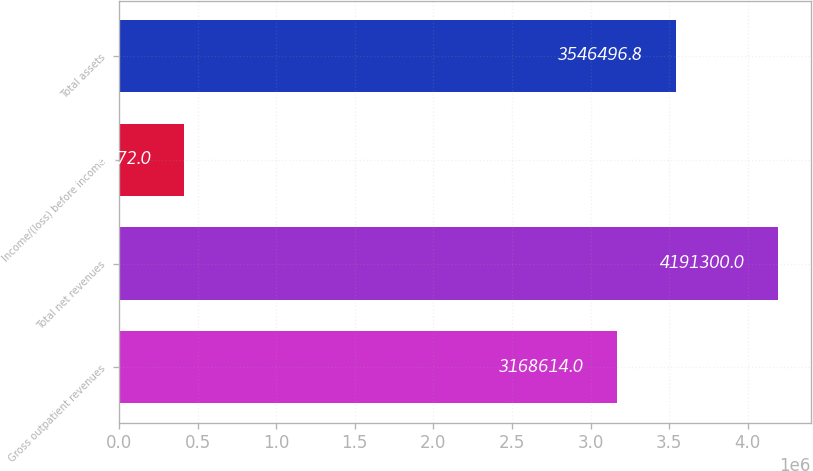<chart> <loc_0><loc_0><loc_500><loc_500><bar_chart><fcel>Gross outpatient revenues<fcel>Total net revenues<fcel>Income/(loss) before income<fcel>Total assets<nl><fcel>3.16861e+06<fcel>4.1913e+06<fcel>412472<fcel>3.5465e+06<nl></chart> 